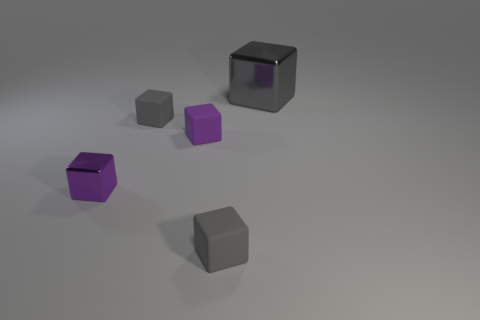Are there any other things that have the same size as the gray metallic cube?
Give a very brief answer. No. The rubber cube that is in front of the small purple metal object is what color?
Your response must be concise. Gray. What is the color of the other shiny object that is the same shape as the purple metallic thing?
Offer a very short reply. Gray. How many big gray cubes are in front of the metal object that is on the right side of the metallic object that is left of the large metal block?
Your answer should be compact. 0. Are there fewer large objects that are behind the large metal thing than purple shiny objects?
Offer a very short reply. Yes. Is the big block the same color as the small shiny block?
Your answer should be compact. No. The gray shiny thing that is the same shape as the small purple matte thing is what size?
Keep it short and to the point. Large. What number of gray cylinders have the same material as the large block?
Your answer should be compact. 0. Are the thing that is in front of the purple shiny object and the large gray object made of the same material?
Offer a very short reply. No. Are there an equal number of tiny gray matte cubes that are to the left of the small purple metallic block and large brown cylinders?
Offer a very short reply. Yes. 